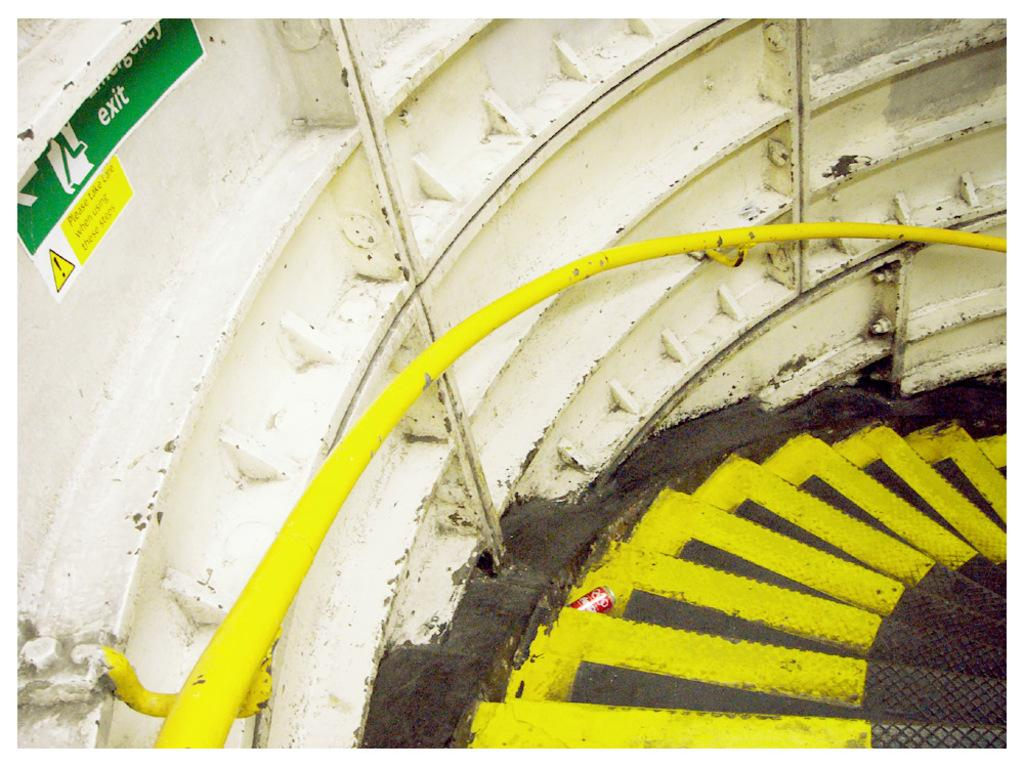What is the main subject of the image? The main subject of the image is stars. What colors are the stars in the image? The stars are in black and yellow color. What is the color of the surface in the background of the image? The surface in the background of the image is white. What other object can be seen in the image? There is a sign board in the image. What type of wood is used to make the whip in the image? There is no whip present in the image; it features stars in black and yellow color with a white background and a sign board. 